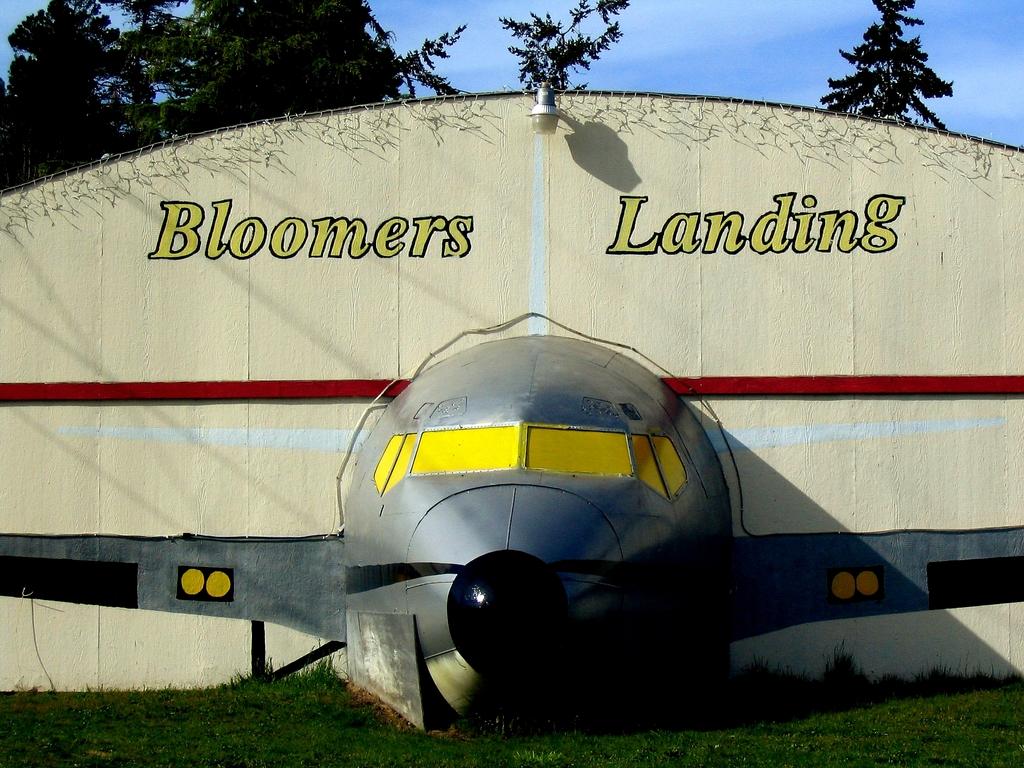What is the name of the hagar?
Give a very brief answer. Bloomers landing. 